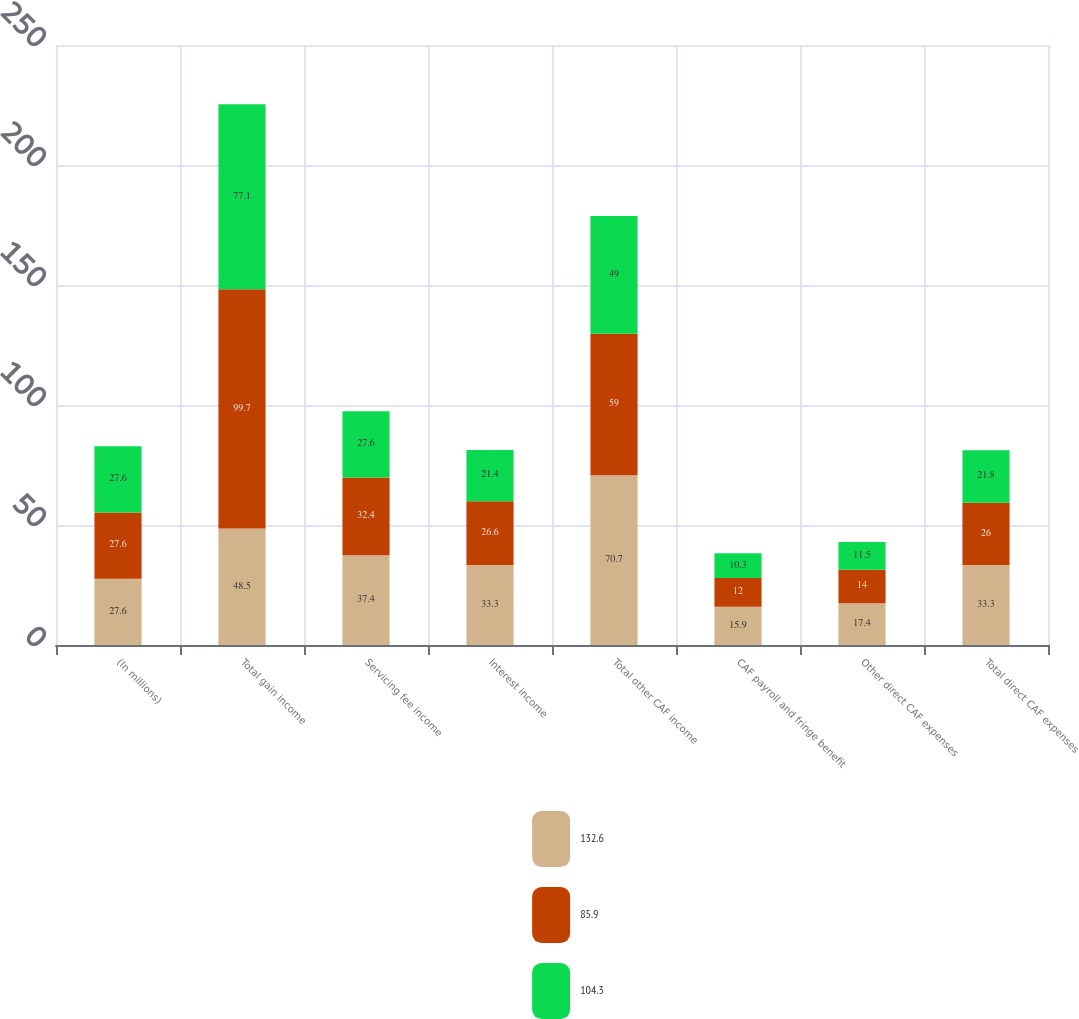<chart> <loc_0><loc_0><loc_500><loc_500><stacked_bar_chart><ecel><fcel>(In millions)<fcel>Total gain income<fcel>Servicing fee income<fcel>Interest income<fcel>Total other CAF income<fcel>CAF payroll and fringe benefit<fcel>Other direct CAF expenses<fcel>Total direct CAF expenses<nl><fcel>132.6<fcel>27.6<fcel>48.5<fcel>37.4<fcel>33.3<fcel>70.7<fcel>15.9<fcel>17.4<fcel>33.3<nl><fcel>85.9<fcel>27.6<fcel>99.7<fcel>32.4<fcel>26.6<fcel>59<fcel>12<fcel>14<fcel>26<nl><fcel>104.3<fcel>27.6<fcel>77.1<fcel>27.6<fcel>21.4<fcel>49<fcel>10.3<fcel>11.5<fcel>21.8<nl></chart> 